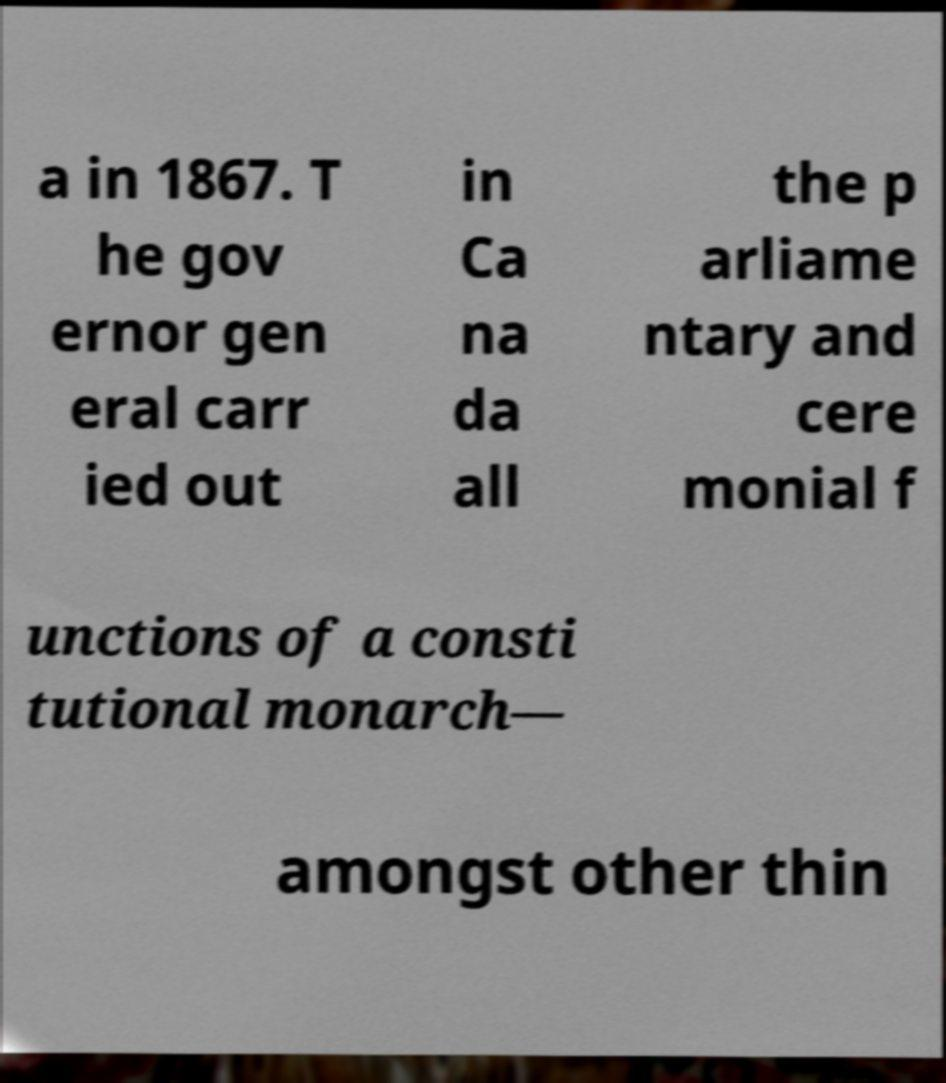For documentation purposes, I need the text within this image transcribed. Could you provide that? a in 1867. T he gov ernor gen eral carr ied out in Ca na da all the p arliame ntary and cere monial f unctions of a consti tutional monarch— amongst other thin 